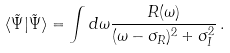Convert formula to latex. <formula><loc_0><loc_0><loc_500><loc_500>\langle \tilde { \Psi } | \tilde { \Psi } \rangle = \int d \omega { \frac { R ( \omega ) } { ( \omega - \sigma _ { R } ) ^ { 2 } + \sigma _ { I } ^ { 2 } } } \, .</formula> 